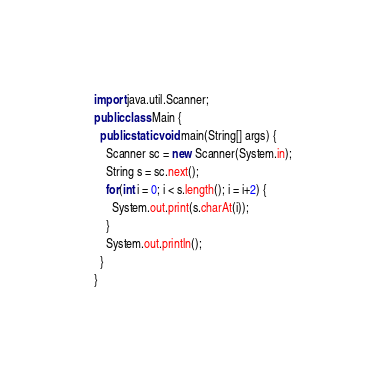Convert code to text. <code><loc_0><loc_0><loc_500><loc_500><_Java_>import java.util.Scanner;
public class Main {
  public static void main(String[] args) {
    Scanner sc = new Scanner(System.in);
    String s = sc.next();
    for(int i = 0; i < s.length(); i = i+2) {
      System.out.print(s.charAt(i));
    }
    System.out.println();
  }
}
</code> 